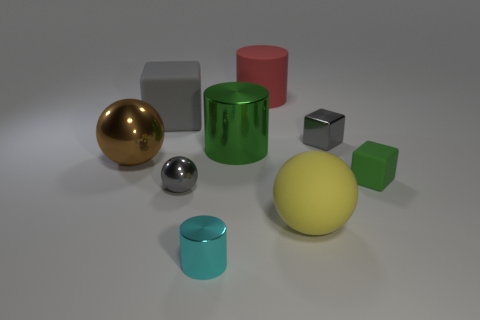Add 1 small gray metallic objects. How many objects exist? 10 Subtract all cubes. How many objects are left? 6 Add 7 tiny gray metal things. How many tiny gray metal things are left? 9 Add 2 green matte spheres. How many green matte spheres exist? 2 Subtract 0 cyan blocks. How many objects are left? 9 Subtract all small brown matte cylinders. Subtract all big matte cylinders. How many objects are left? 8 